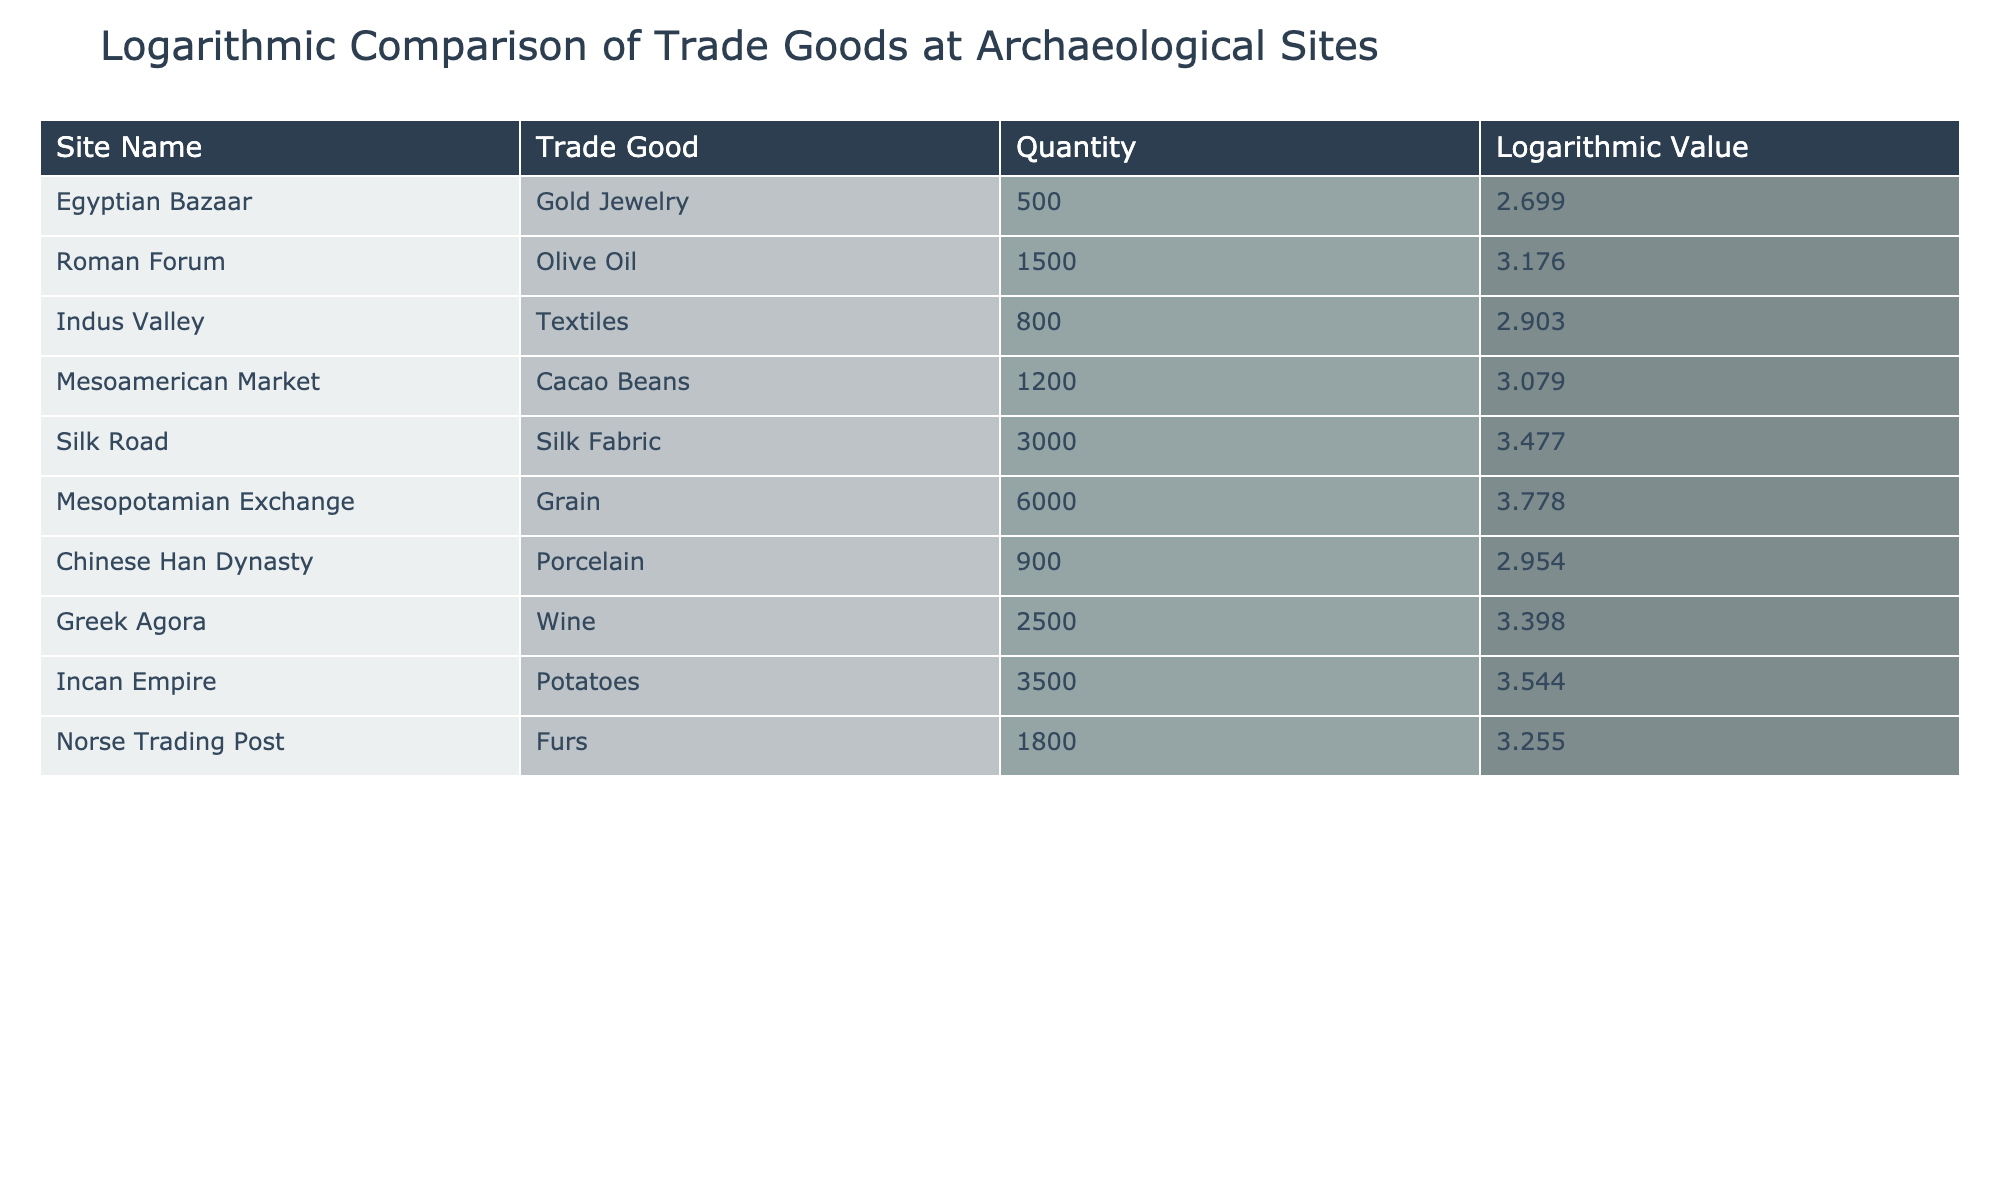What is the logarithmic value of Gold Jewelry found in the Egyptian Bazaar? The table shows that Gold Jewelry from the Egyptian Bazaar has a logarithmic value of 2.699 specifically listed under the "Logarithmic Value" column.
Answer: 2.699 Which site shows the highest logarithmic value for trade goods? By comparing the logarithmic values from the table, Mesopotamian Exchange has the highest value of 3.778 for Grain.
Answer: 3.778 What is the average logarithmic value of trade goods across all sites? To find the average, sum up all logarithmic values: 2.699 + 3.176 + 2.903 + 3.079 + 3.477 + 3.778 + 2.954 + 3.398 + 3.544 + 3.255 = 30.906. Then, divide by the number of sites, which is 10. Therefore, 30.906 / 10 = 3.0906.
Answer: 3.0906 Did the Norse Trading Post have a larger quantity of trade goods compared to the Egyptian Bazaar? The quantity for Norse Trading Post is 1800, while for Egyptian Bazaar it is 500. Since 1800 is greater than 500, the answer is yes.
Answer: Yes What is the difference in logarithmic value between the Greek Agora's Wine and the Roman Forum's Olive Oil? The logarithmic value for Greek Agora's Wine is 3.398, and for Roman Forum's Olive Oil, it is 3.176. Thus, the difference is 3.398 - 3.176 = 0.222.
Answer: 0.222 Which site had the trade good with the largest quantity, and what is that quantity? The Mesopotamian Exchange had the trade good with the largest quantity, which is Grain totaling 6000 units. This is determined by comparing all the quantities listed for each site.
Answer: 6000 Is it true that the Chinese Han Dynasty had a lower logarithmic value than the Incan Empire? The logarithmic value for Chinese Han Dynasty's Porcelain is 2.954, whereas for Incan Empire's Potatoes, it is 3.544. As 2.954 is less than 3.544, the statement is true.
Answer: True What is the sum of the quantities for trade goods found in both the Mesoamerican Market and the Incan Empire? The quantity for Mesoamerican Market's Cacao Beans is 1200 and for Incan Empire's Potatoes is 3500. Adding these quantities together gives 1200 + 3500 = 4700.
Answer: 4700 Compare the logarithmic values of the Silk Road and the Greek Agora; which one is greater? The logarithmic value for Silk Road's Silk Fabric is 3.477, and for Greek Agora's Wine, it's 3.398. Since 3.477 is greater than 3.398, Silk Road has the higher value.
Answer: Silk Road 